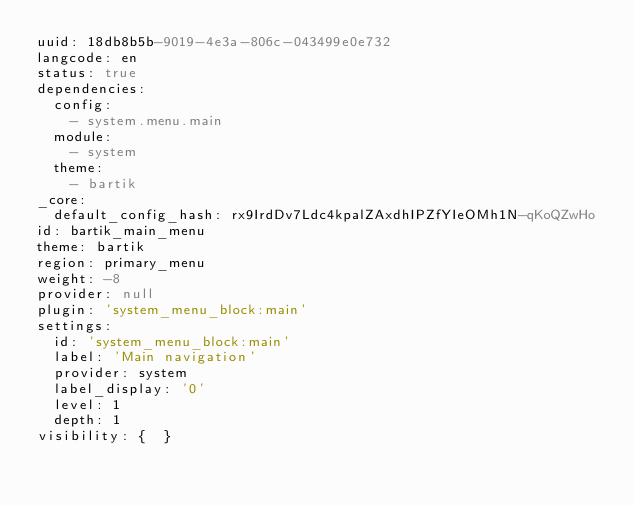<code> <loc_0><loc_0><loc_500><loc_500><_YAML_>uuid: 18db8b5b-9019-4e3a-806c-043499e0e732
langcode: en
status: true
dependencies:
  config:
    - system.menu.main
  module:
    - system
  theme:
    - bartik
_core:
  default_config_hash: rx9IrdDv7Ldc4kpalZAxdhIPZfYIeOMh1N-qKoQZwHo
id: bartik_main_menu
theme: bartik
region: primary_menu
weight: -8
provider: null
plugin: 'system_menu_block:main'
settings:
  id: 'system_menu_block:main'
  label: 'Main navigation'
  provider: system
  label_display: '0'
  level: 1
  depth: 1
visibility: {  }
</code> 